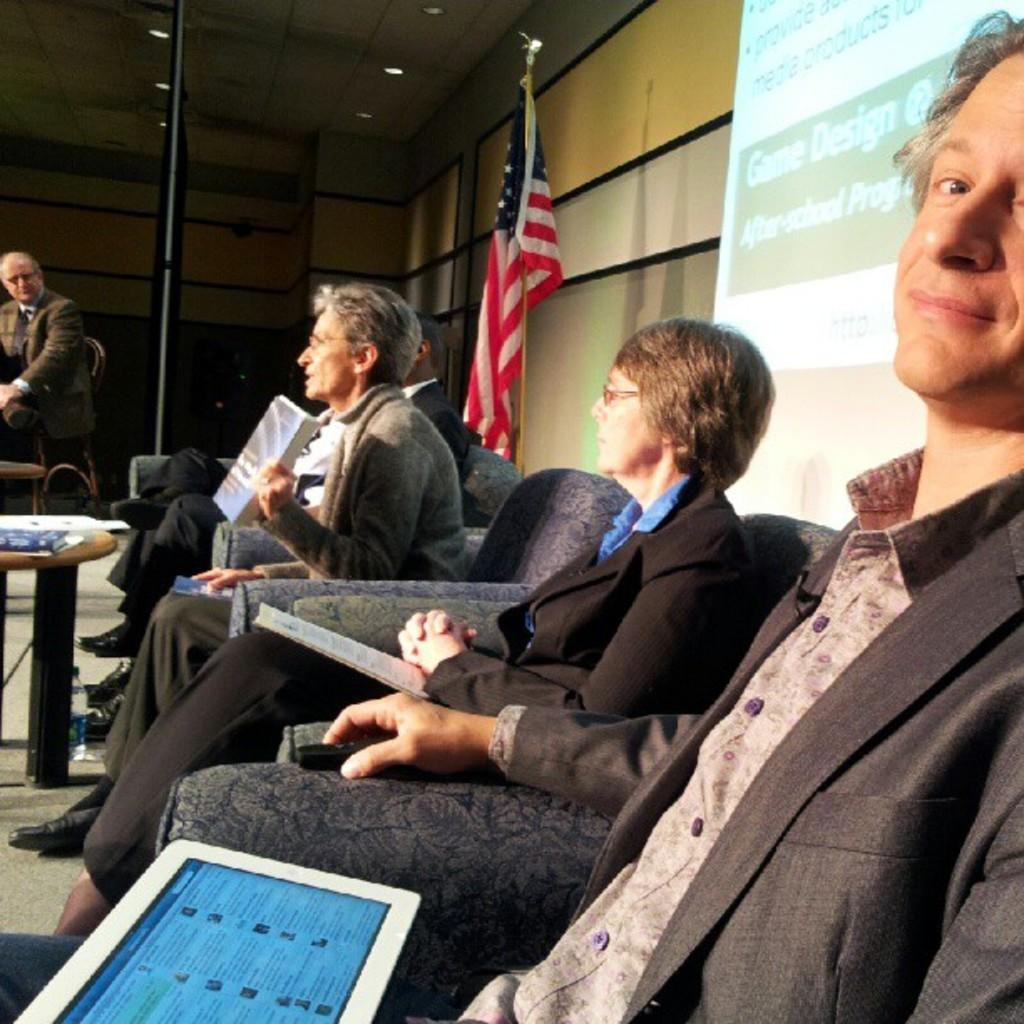What are the people in the image doing? The people in the image are sitting on chairs and holding tablets and books in their hands. What objects can be seen in the hands of the people? The people are holding tablets and books in their hands. What is visible in the background of the image? There is a display screen, a flag, a flag post, and a side table visible in the background of the image. Can you describe the zephyr blowing across the hill in the image? There is no zephyr or hill present in the image. What type of coast can be seen in the background of the image? There is no coast visible in the image; it features a display screen, a flag, a flag post, and a side table in the background. 